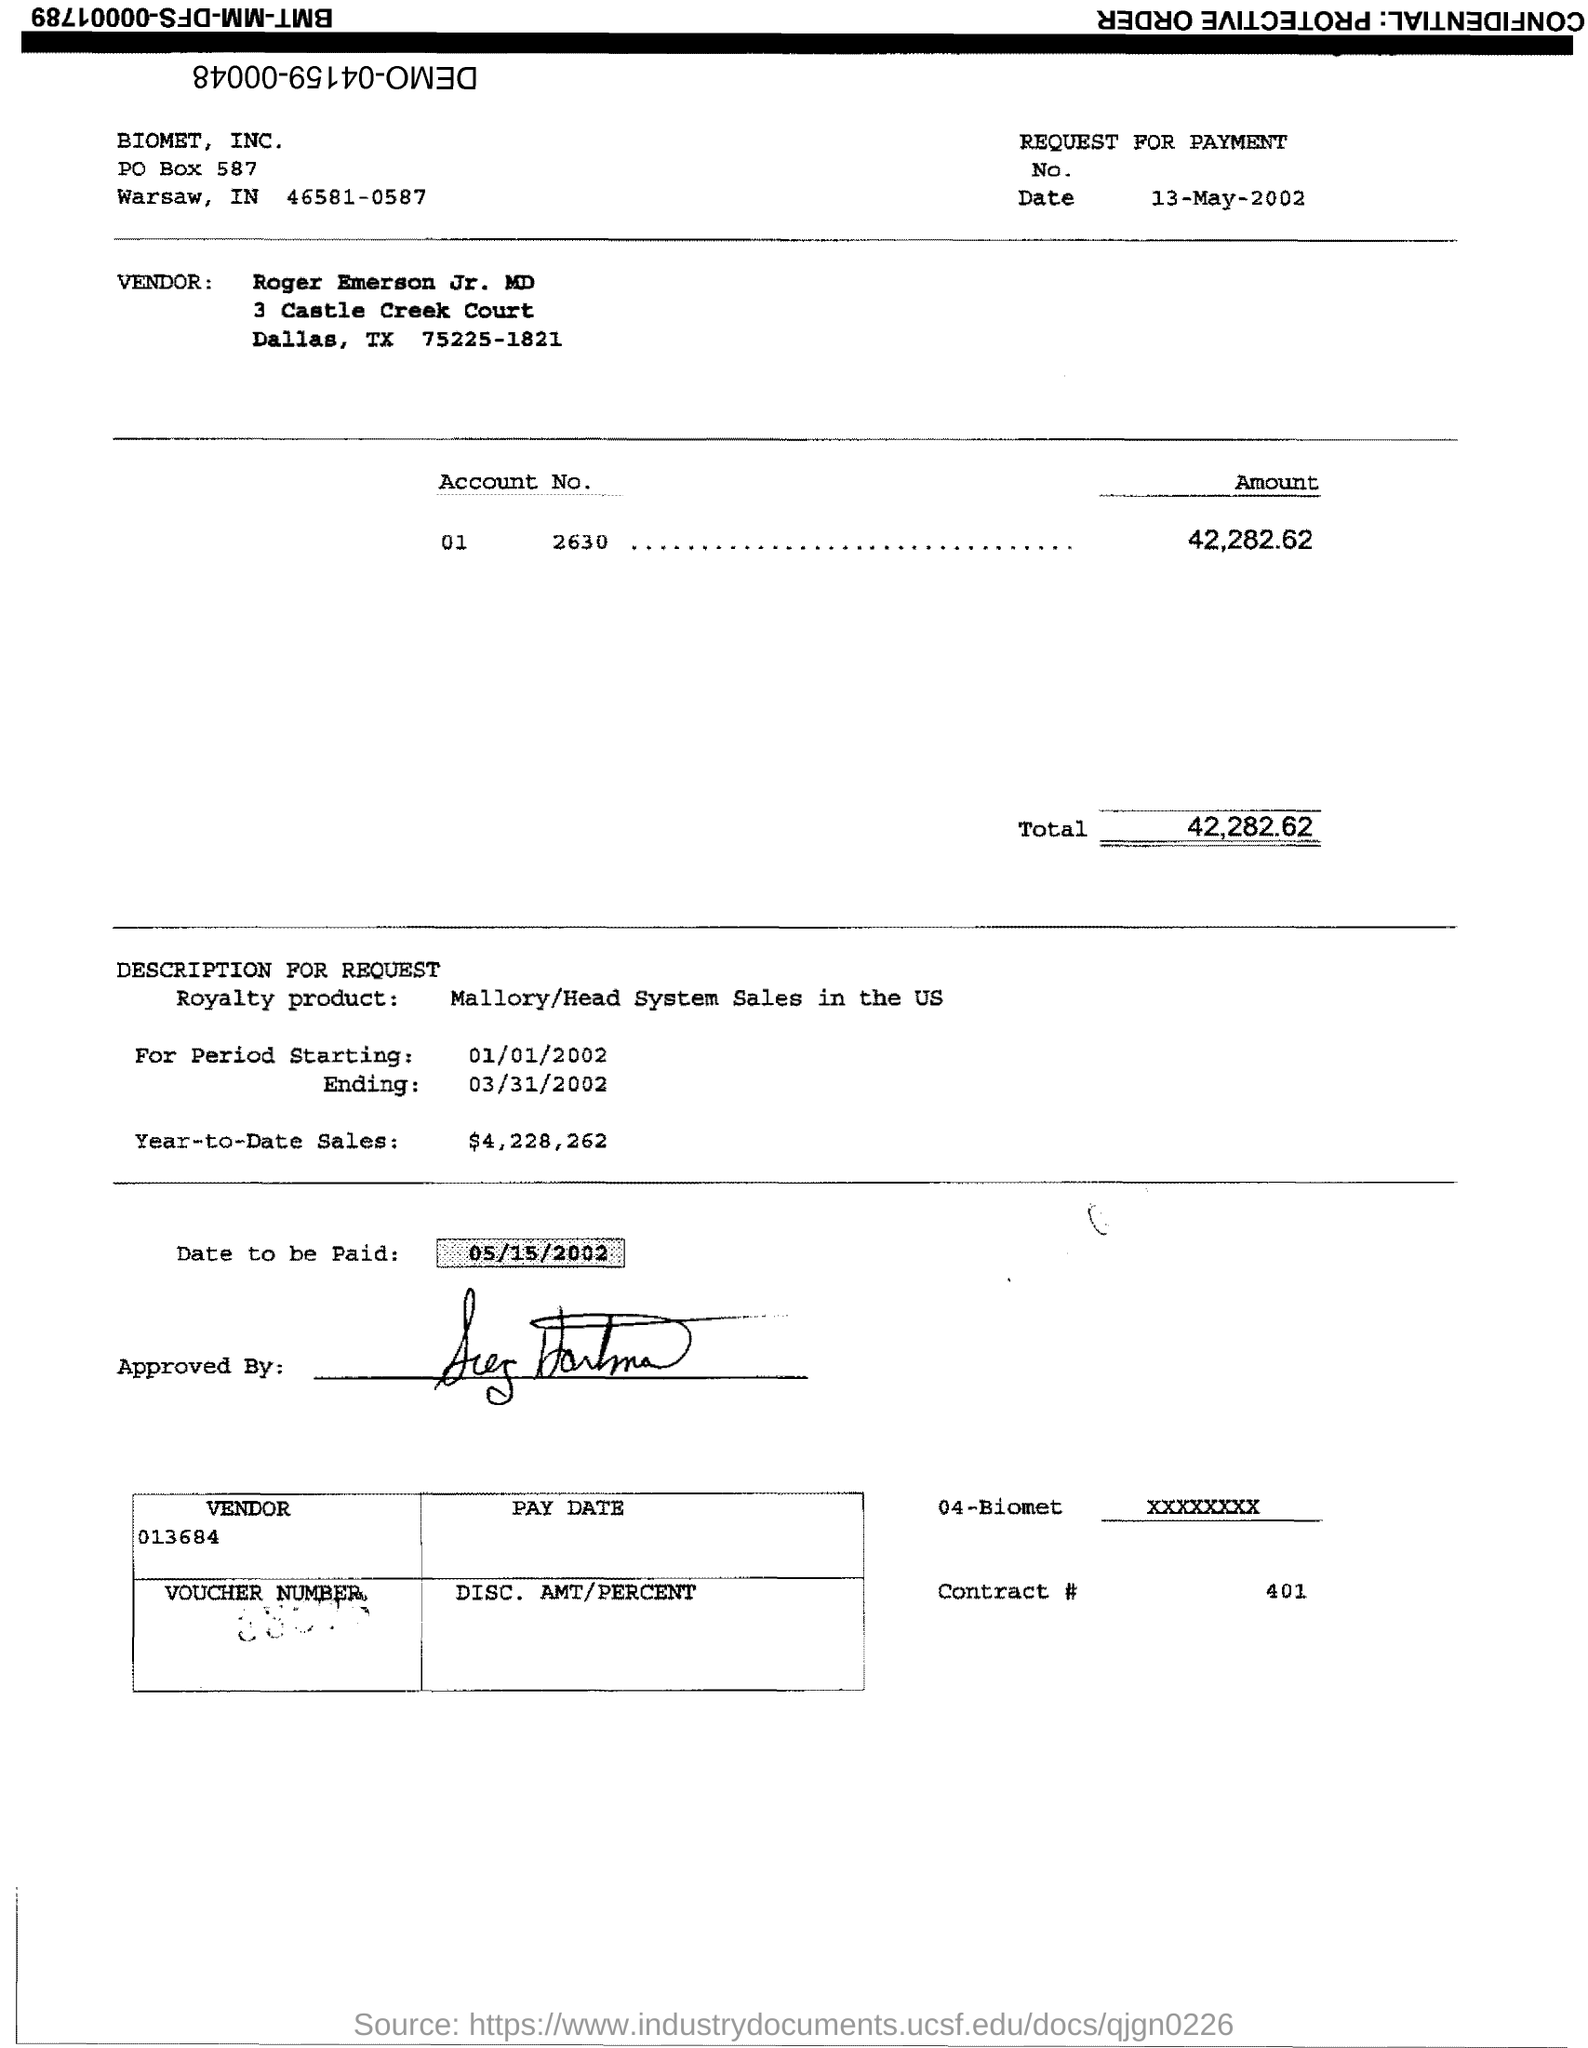What product is referenced in the document, and what sales figure is associated with it? The document references royalty product sales for the 'Mallory/Head System' in the US, with the year-to-date sales figure quoted as $4,228,262. 